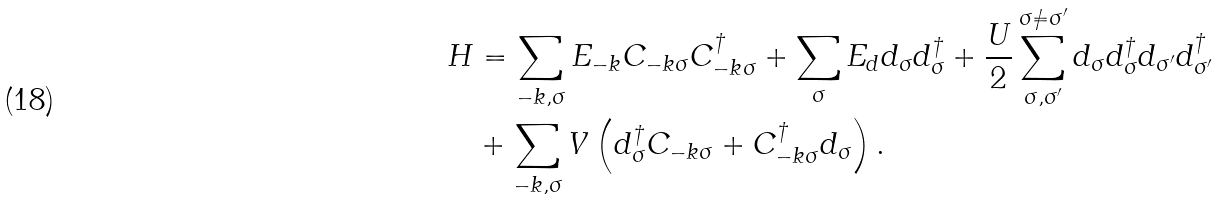<formula> <loc_0><loc_0><loc_500><loc_500>H & = \sum _ { - k , \sigma } E _ { - k } C _ { - k \sigma } C _ { - k \sigma } ^ { \dagger } + \sum _ { \sigma } E _ { d } d _ { \sigma } d _ { \sigma } ^ { \dagger } + \frac { U } { 2 } \sum ^ { \sigma \not = \sigma ^ { \prime } } _ { \sigma , \sigma ^ { \prime } } d _ { \sigma } d _ { \sigma } ^ { \dagger } d _ { \sigma ^ { \prime } } d _ { \sigma ^ { \prime } } ^ { \dagger } \\ & + \sum _ { { - k } , \sigma } V \left ( d _ { \sigma } ^ { \dagger } C _ { { - k } \sigma } + C _ { { - k } \sigma } ^ { \dagger } d _ { \sigma } \right ) .</formula> 